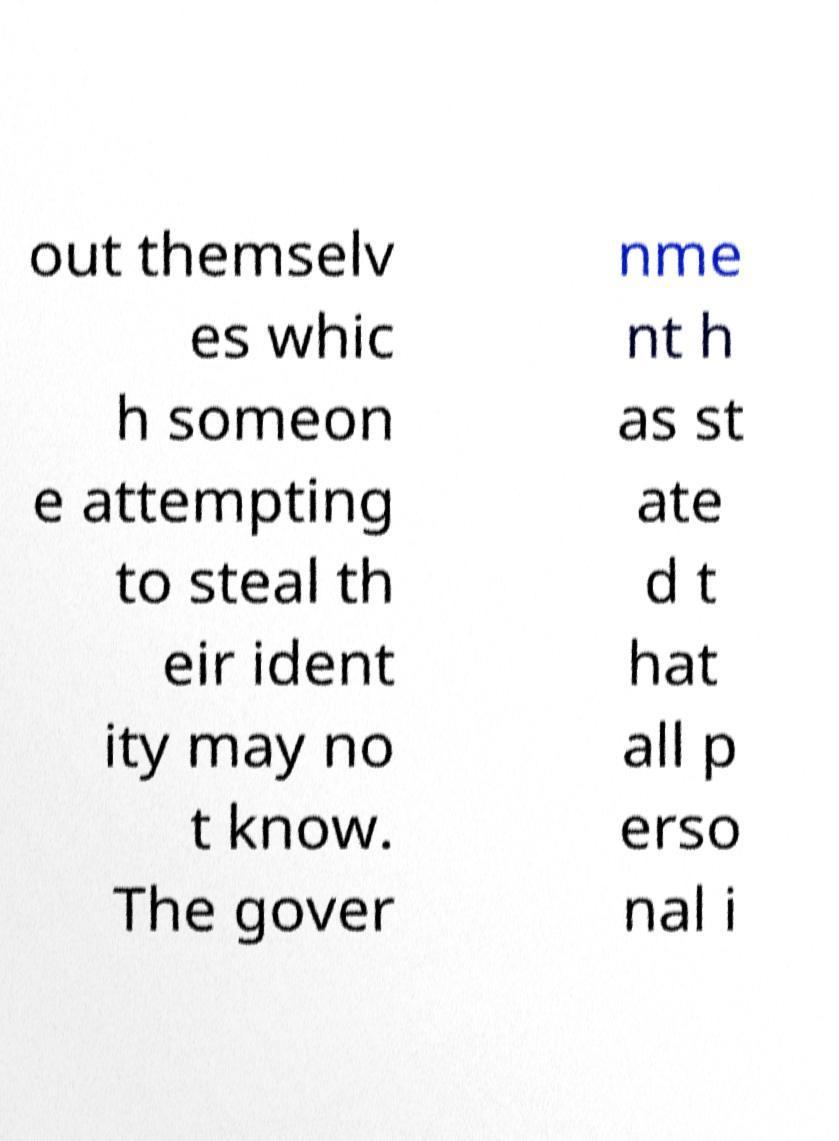Are there any implications in this text for personal privacy or security? Yes, the text hints at the risks associated with identity theft and the importance of keeping certain personal information private. The government's involvement suggests that there might be legal or regulatory frameworks intended to protect individuals' personal data. 